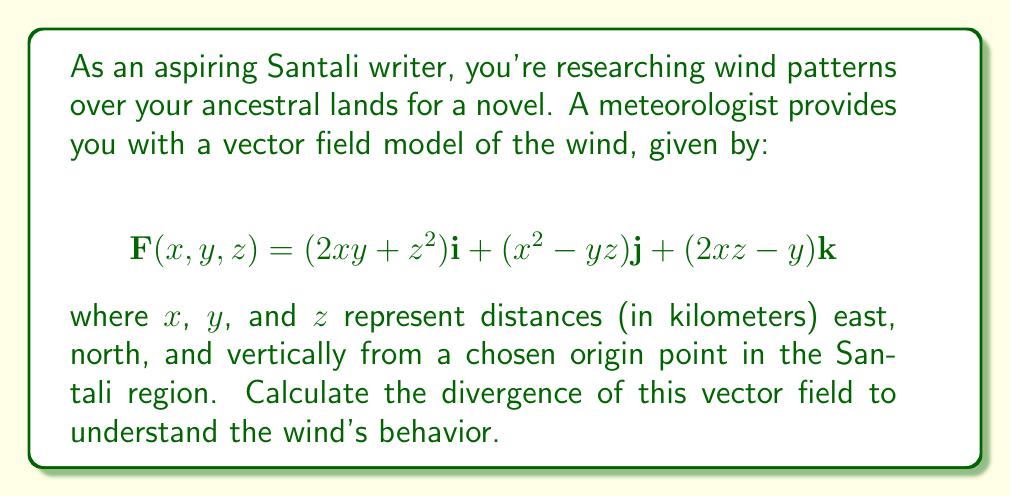Could you help me with this problem? To find the divergence of the vector field, we need to calculate the partial derivatives of each component with respect to its corresponding variable and sum them up. The divergence is given by:

$$\text{div}\mathbf{F} = \nabla \cdot \mathbf{F} = \frac{\partial F_x}{\partial x} + \frac{\partial F_y}{\partial y} + \frac{\partial F_z}{\partial z}$$

Let's calculate each partial derivative:

1) $\frac{\partial F_x}{\partial x}$:
   $F_x = 2xy + z^2$
   $\frac{\partial F_x}{\partial x} = 2y$

2) $\frac{\partial F_y}{\partial y}$:
   $F_y = x^2 - yz$
   $\frac{\partial F_y}{\partial y} = -z$

3) $\frac{\partial F_z}{\partial z}$:
   $F_z = 2xz - y$
   $\frac{\partial F_z}{\partial z} = 2x$

Now, we sum these partial derivatives:

$$\text{div}\mathbf{F} = \frac{\partial F_x}{\partial x} + \frac{\partial F_y}{\partial y} + \frac{\partial F_z}{\partial z}$$
$$\text{div}\mathbf{F} = 2y - z + 2x$$

This is the divergence of the wind vector field over the Santali lands.
Answer: $2y - z + 2x$ 